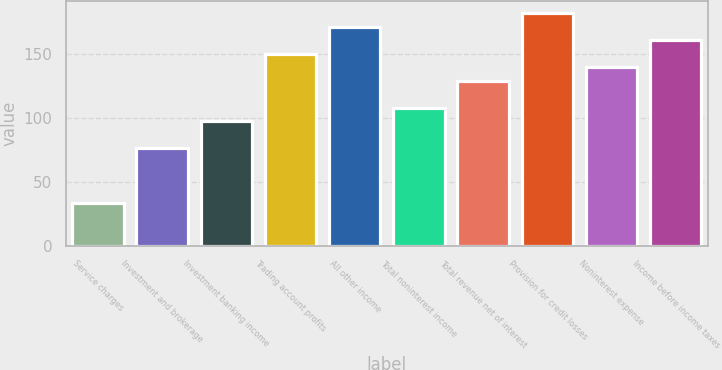<chart> <loc_0><loc_0><loc_500><loc_500><bar_chart><fcel>Service charges<fcel>Investment and brokerage<fcel>Investment banking income<fcel>Trading account profits<fcel>All other income<fcel>Total noninterest income<fcel>Total revenue net of interest<fcel>Provision for credit losses<fcel>Noninterest expense<fcel>Income before income taxes<nl><fcel>33.8<fcel>76.2<fcel>97.4<fcel>150.4<fcel>171.6<fcel>108<fcel>129.2<fcel>182.2<fcel>139.8<fcel>161<nl></chart> 